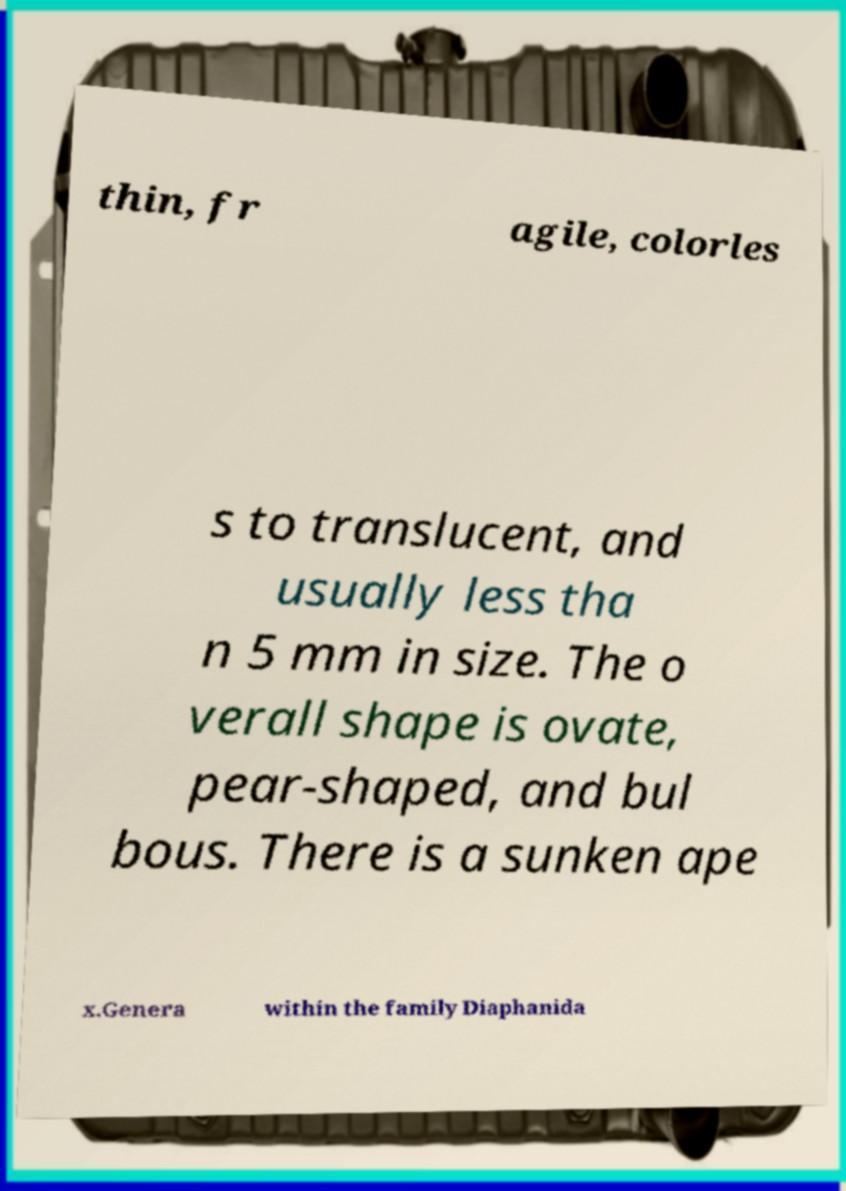I need the written content from this picture converted into text. Can you do that? thin, fr agile, colorles s to translucent, and usually less tha n 5 mm in size. The o verall shape is ovate, pear-shaped, and bul bous. There is a sunken ape x.Genera within the family Diaphanida 